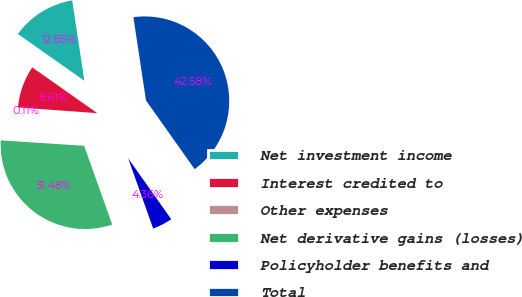Convert chart to OTSL. <chart><loc_0><loc_0><loc_500><loc_500><pie_chart><fcel>Net investment income<fcel>Interest credited to<fcel>Other expenses<fcel>Net derivative gains (losses)<fcel>Policyholder benefits and<fcel>Total<nl><fcel>12.85%<fcel>8.61%<fcel>0.11%<fcel>31.48%<fcel>4.36%<fcel>42.58%<nl></chart> 